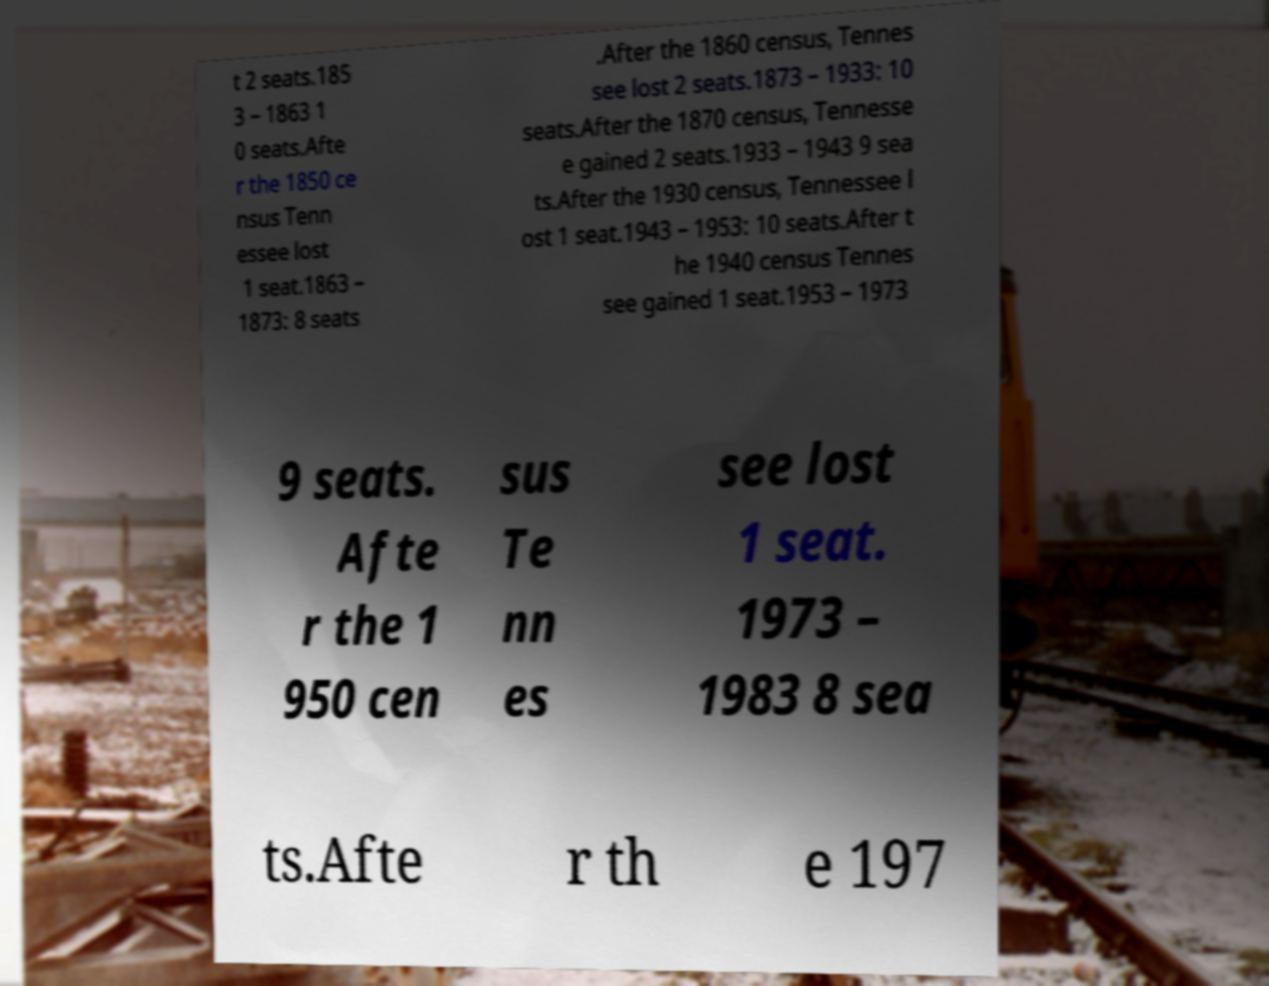Could you extract and type out the text from this image? t 2 seats.185 3 – 1863 1 0 seats.Afte r the 1850 ce nsus Tenn essee lost 1 seat.1863 – 1873: 8 seats .After the 1860 census, Tennes see lost 2 seats.1873 – 1933: 10 seats.After the 1870 census, Tennesse e gained 2 seats.1933 – 1943 9 sea ts.After the 1930 census, Tennessee l ost 1 seat.1943 – 1953: 10 seats.After t he 1940 census Tennes see gained 1 seat.1953 – 1973 9 seats. Afte r the 1 950 cen sus Te nn es see lost 1 seat. 1973 – 1983 8 sea ts.Afte r th e 197 